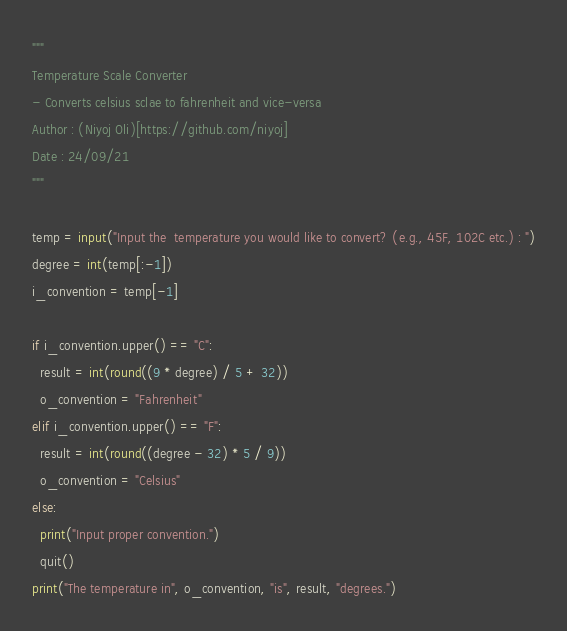<code> <loc_0><loc_0><loc_500><loc_500><_Python_>"""
Temperature Scale Converter
- Converts celsius sclae to fahrenheit and vice-versa
Author : (Niyoj Oli)[https://github.com/niyoj]
Date : 24/09/21
"""

temp = input("Input the  temperature you would like to convert? (e.g., 45F, 102C etc.) : ")
degree = int(temp[:-1])
i_convention = temp[-1]

if i_convention.upper() == "C":
  result = int(round((9 * degree) / 5 + 32))
  o_convention = "Fahrenheit"
elif i_convention.upper() == "F":
  result = int(round((degree - 32) * 5 / 9))
  o_convention = "Celsius"
else:
  print("Input proper convention.")
  quit()
print("The temperature in", o_convention, "is", result, "degrees.")
</code> 